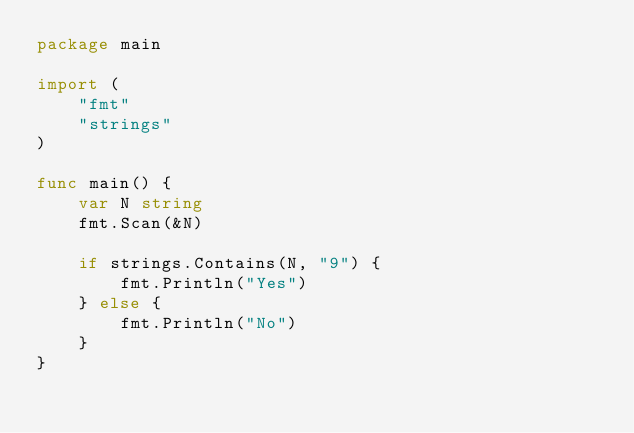Convert code to text. <code><loc_0><loc_0><loc_500><loc_500><_Go_>package main

import (
	"fmt"
	"strings"
)

func main() {
	var N string
	fmt.Scan(&N)

	if strings.Contains(N, "9") {
		fmt.Println("Yes")
	} else {
		fmt.Println("No")
	}
}
</code> 